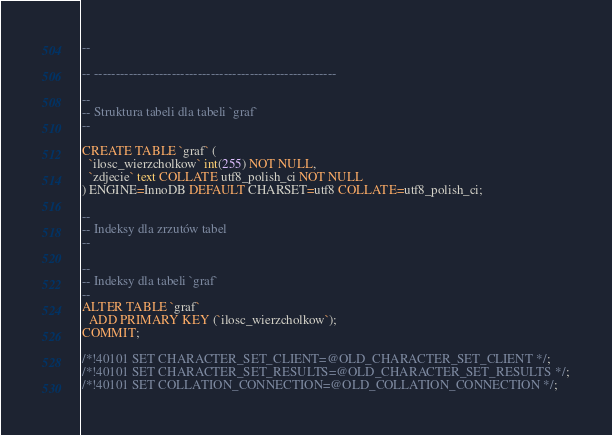<code> <loc_0><loc_0><loc_500><loc_500><_SQL_>--

-- --------------------------------------------------------

--
-- Struktura tabeli dla tabeli `graf`
--

CREATE TABLE `graf` (
  `ilosc_wierzcholkow` int(255) NOT NULL,
  `zdjecie` text COLLATE utf8_polish_ci NOT NULL
) ENGINE=InnoDB DEFAULT CHARSET=utf8 COLLATE=utf8_polish_ci;

--
-- Indeksy dla zrzutów tabel
--

--
-- Indeksy dla tabeli `graf`
--
ALTER TABLE `graf`
  ADD PRIMARY KEY (`ilosc_wierzcholkow`);
COMMIT;

/*!40101 SET CHARACTER_SET_CLIENT=@OLD_CHARACTER_SET_CLIENT */;
/*!40101 SET CHARACTER_SET_RESULTS=@OLD_CHARACTER_SET_RESULTS */;
/*!40101 SET COLLATION_CONNECTION=@OLD_COLLATION_CONNECTION */;
</code> 